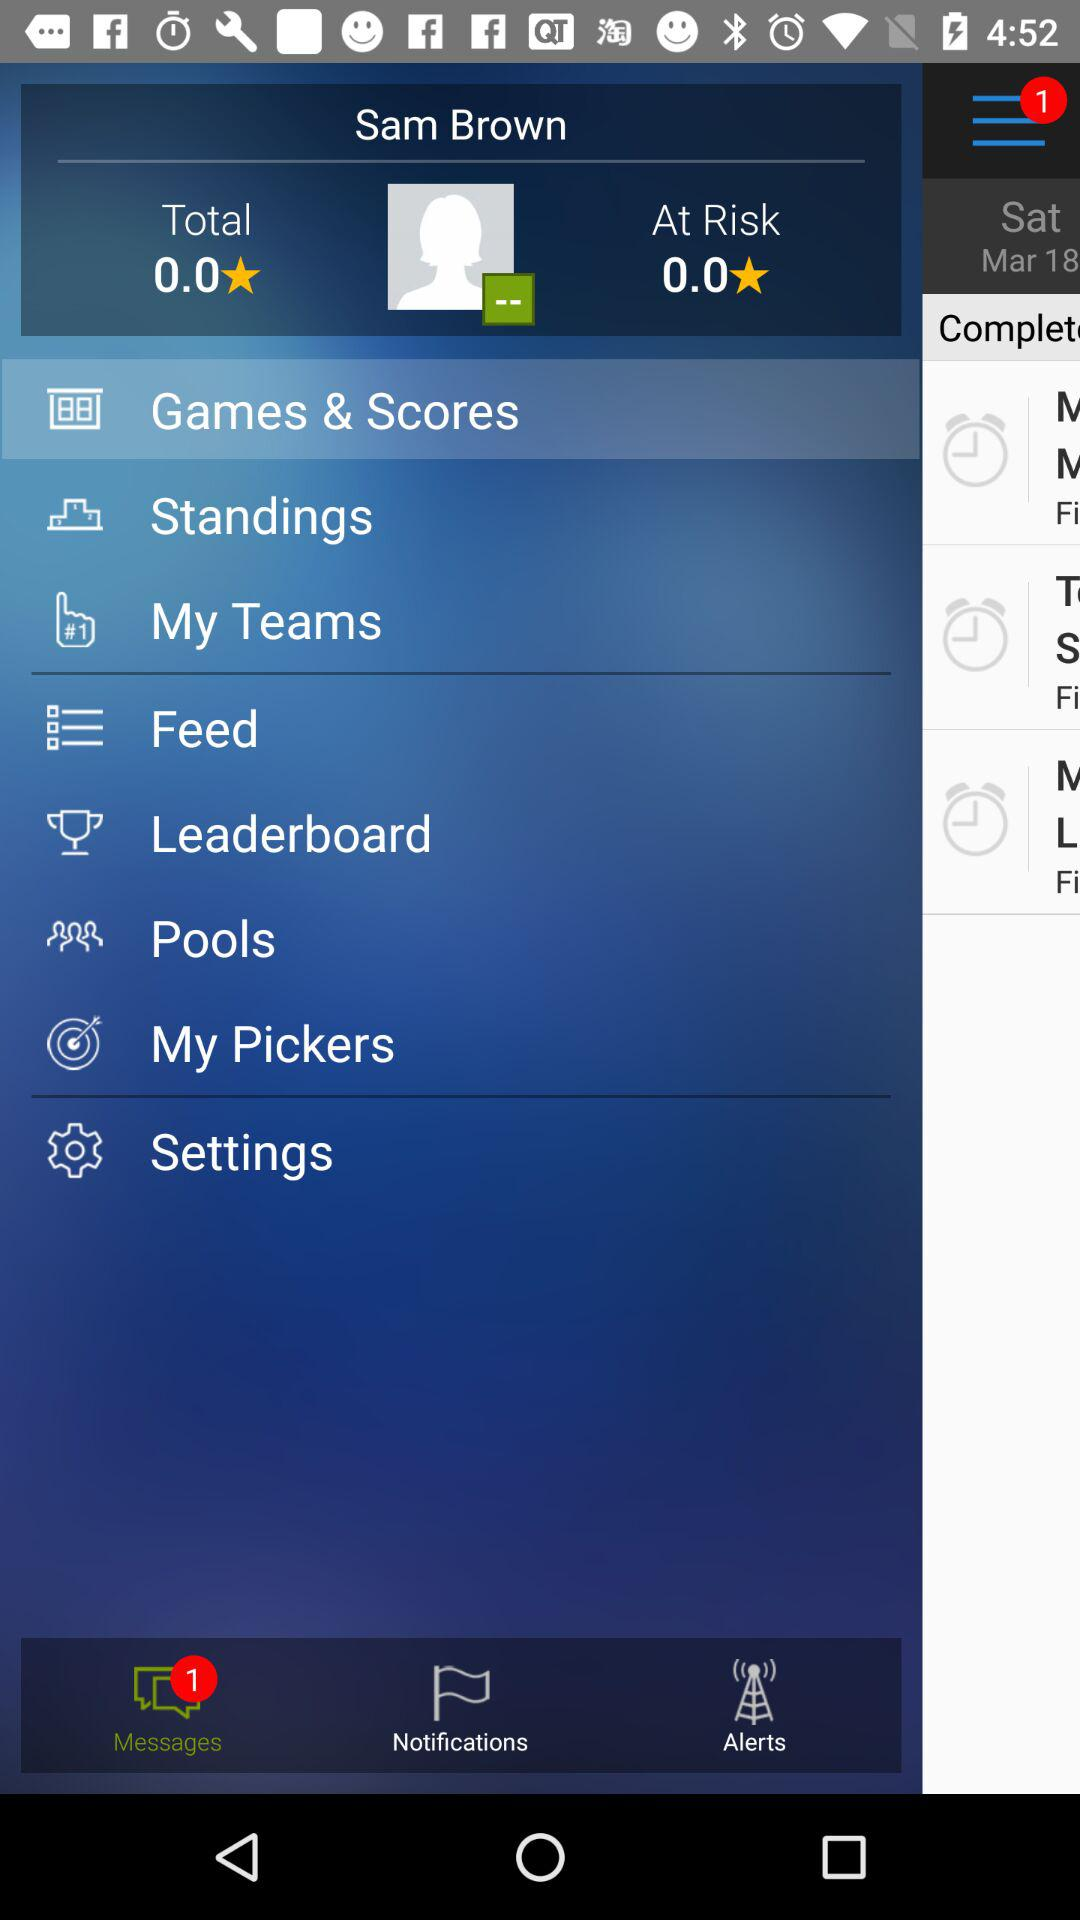How many stars are there in total? There are 0 stars. 